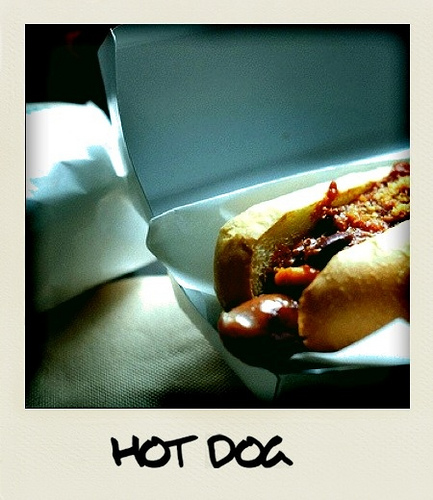Please transcribe the text information in this image. HOT DOG 